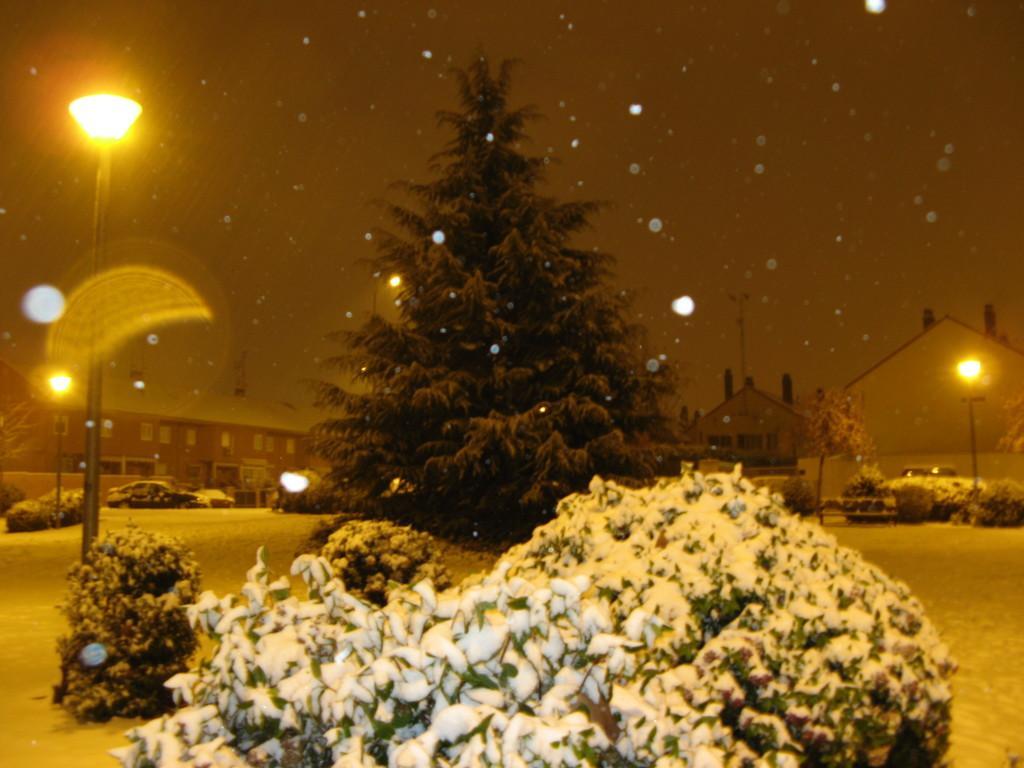Could you give a brief overview of what you see in this image? In front of the image there are bushes covered with snow, behind the bushes there are lamp posts, trees and buildings, in front of the buildings there are a few cars parked and there is snow on the surface. 